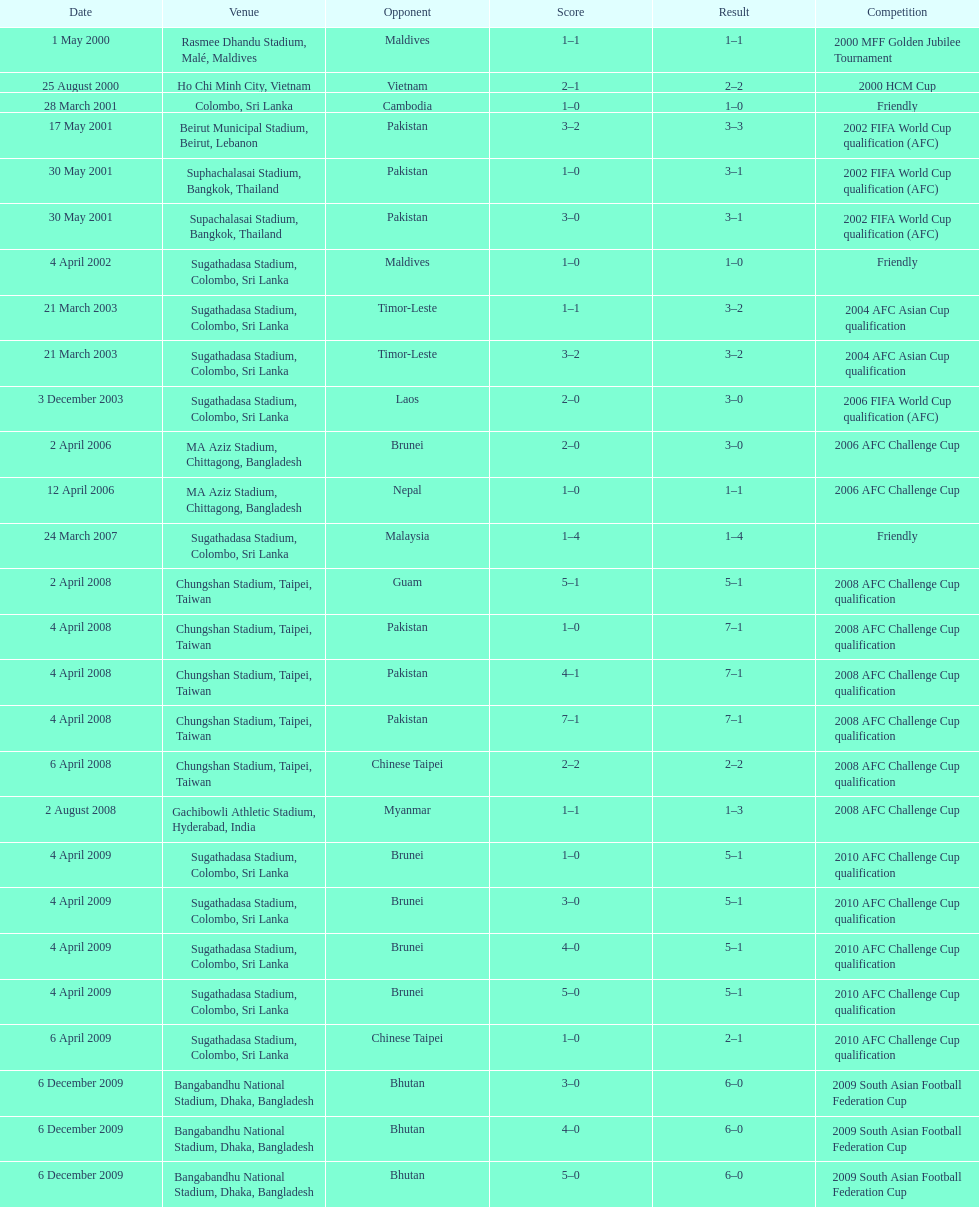What was the next venue after colombo, sri lanka on march 28? Beirut Municipal Stadium, Beirut, Lebanon. 